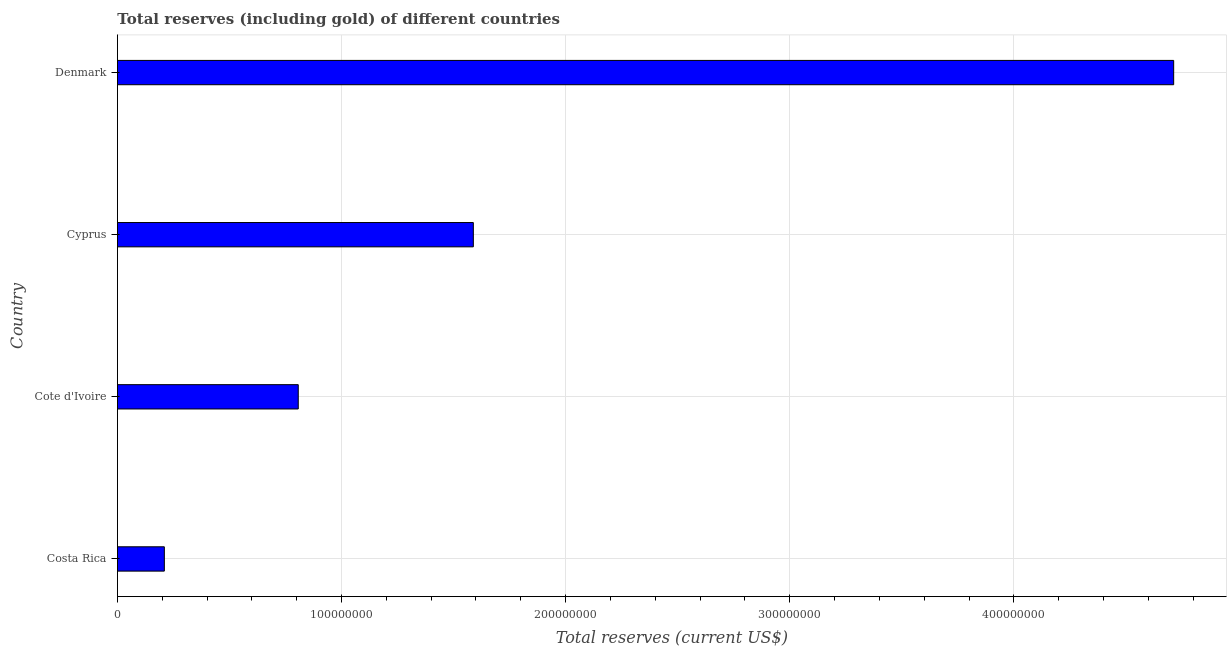Does the graph contain any zero values?
Your answer should be compact. No. Does the graph contain grids?
Your answer should be very brief. Yes. What is the title of the graph?
Ensure brevity in your answer.  Total reserves (including gold) of different countries. What is the label or title of the X-axis?
Make the answer very short. Total reserves (current US$). What is the label or title of the Y-axis?
Keep it short and to the point. Country. What is the total reserves (including gold) in Cote d'Ivoire?
Your answer should be compact. 8.07e+07. Across all countries, what is the maximum total reserves (including gold)?
Offer a very short reply. 4.71e+08. Across all countries, what is the minimum total reserves (including gold)?
Provide a succinct answer. 2.09e+07. In which country was the total reserves (including gold) maximum?
Give a very brief answer. Denmark. What is the sum of the total reserves (including gold)?
Keep it short and to the point. 7.32e+08. What is the difference between the total reserves (including gold) in Costa Rica and Denmark?
Keep it short and to the point. -4.50e+08. What is the average total reserves (including gold) per country?
Offer a very short reply. 1.83e+08. What is the median total reserves (including gold)?
Ensure brevity in your answer.  1.20e+08. What is the ratio of the total reserves (including gold) in Cote d'Ivoire to that in Cyprus?
Offer a terse response. 0.51. Is the total reserves (including gold) in Cote d'Ivoire less than that in Cyprus?
Make the answer very short. Yes. Is the difference between the total reserves (including gold) in Costa Rica and Denmark greater than the difference between any two countries?
Provide a short and direct response. Yes. What is the difference between the highest and the second highest total reserves (including gold)?
Your response must be concise. 3.13e+08. Is the sum of the total reserves (including gold) in Costa Rica and Cyprus greater than the maximum total reserves (including gold) across all countries?
Give a very brief answer. No. What is the difference between the highest and the lowest total reserves (including gold)?
Your answer should be very brief. 4.50e+08. In how many countries, is the total reserves (including gold) greater than the average total reserves (including gold) taken over all countries?
Offer a terse response. 1. How many bars are there?
Provide a succinct answer. 4. How many countries are there in the graph?
Give a very brief answer. 4. What is the Total reserves (current US$) of Costa Rica?
Give a very brief answer. 2.09e+07. What is the Total reserves (current US$) in Cote d'Ivoire?
Provide a short and direct response. 8.07e+07. What is the Total reserves (current US$) in Cyprus?
Provide a short and direct response. 1.59e+08. What is the Total reserves (current US$) in Denmark?
Make the answer very short. 4.71e+08. What is the difference between the Total reserves (current US$) in Costa Rica and Cote d'Ivoire?
Give a very brief answer. -5.98e+07. What is the difference between the Total reserves (current US$) in Costa Rica and Cyprus?
Your answer should be compact. -1.38e+08. What is the difference between the Total reserves (current US$) in Costa Rica and Denmark?
Offer a very short reply. -4.50e+08. What is the difference between the Total reserves (current US$) in Cote d'Ivoire and Cyprus?
Make the answer very short. -7.81e+07. What is the difference between the Total reserves (current US$) in Cote d'Ivoire and Denmark?
Offer a very short reply. -3.91e+08. What is the difference between the Total reserves (current US$) in Cyprus and Denmark?
Make the answer very short. -3.13e+08. What is the ratio of the Total reserves (current US$) in Costa Rica to that in Cote d'Ivoire?
Your answer should be very brief. 0.26. What is the ratio of the Total reserves (current US$) in Costa Rica to that in Cyprus?
Your answer should be compact. 0.13. What is the ratio of the Total reserves (current US$) in Costa Rica to that in Denmark?
Offer a very short reply. 0.04. What is the ratio of the Total reserves (current US$) in Cote d'Ivoire to that in Cyprus?
Give a very brief answer. 0.51. What is the ratio of the Total reserves (current US$) in Cote d'Ivoire to that in Denmark?
Your response must be concise. 0.17. What is the ratio of the Total reserves (current US$) in Cyprus to that in Denmark?
Your response must be concise. 0.34. 